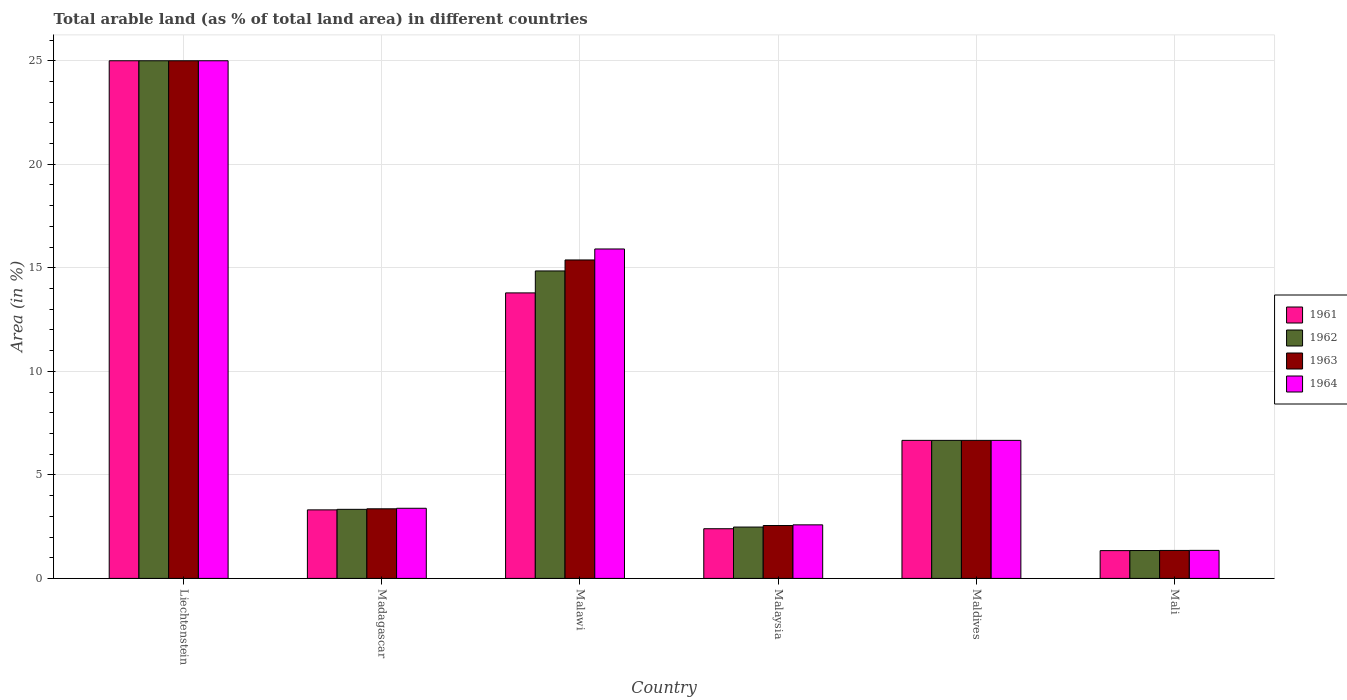How many groups of bars are there?
Offer a very short reply. 6. How many bars are there on the 4th tick from the left?
Your answer should be compact. 4. What is the label of the 1st group of bars from the left?
Provide a short and direct response. Liechtenstein. Across all countries, what is the maximum percentage of arable land in 1964?
Keep it short and to the point. 25. Across all countries, what is the minimum percentage of arable land in 1964?
Your response must be concise. 1.35. In which country was the percentage of arable land in 1962 maximum?
Your answer should be very brief. Liechtenstein. In which country was the percentage of arable land in 1964 minimum?
Offer a terse response. Mali. What is the total percentage of arable land in 1963 in the graph?
Your answer should be very brief. 54.31. What is the difference between the percentage of arable land in 1962 in Malawi and that in Mali?
Offer a very short reply. 13.5. What is the difference between the percentage of arable land in 1961 in Maldives and the percentage of arable land in 1962 in Malaysia?
Make the answer very short. 4.19. What is the average percentage of arable land in 1964 per country?
Offer a terse response. 9.15. In how many countries, is the percentage of arable land in 1964 greater than 13 %?
Give a very brief answer. 2. What is the ratio of the percentage of arable land in 1962 in Malawi to that in Mali?
Offer a terse response. 11.03. Is the percentage of arable land in 1962 in Madagascar less than that in Mali?
Give a very brief answer. No. Is the difference between the percentage of arable land in 1963 in Malawi and Malaysia greater than the difference between the percentage of arable land in 1961 in Malawi and Malaysia?
Make the answer very short. Yes. What is the difference between the highest and the second highest percentage of arable land in 1964?
Your response must be concise. 18.33. What is the difference between the highest and the lowest percentage of arable land in 1963?
Give a very brief answer. 23.65. Is the sum of the percentage of arable land in 1964 in Liechtenstein and Malaysia greater than the maximum percentage of arable land in 1961 across all countries?
Your answer should be very brief. Yes. Is it the case that in every country, the sum of the percentage of arable land in 1961 and percentage of arable land in 1962 is greater than the sum of percentage of arable land in 1964 and percentage of arable land in 1963?
Offer a terse response. No. What does the 1st bar from the right in Mali represents?
Your answer should be very brief. 1964. Does the graph contain any zero values?
Provide a succinct answer. No. Does the graph contain grids?
Offer a very short reply. Yes. What is the title of the graph?
Make the answer very short. Total arable land (as % of total land area) in different countries. What is the label or title of the Y-axis?
Your response must be concise. Area (in %). What is the Area (in %) of 1961 in Liechtenstein?
Your answer should be compact. 25. What is the Area (in %) in 1962 in Liechtenstein?
Keep it short and to the point. 25. What is the Area (in %) of 1963 in Liechtenstein?
Your response must be concise. 25. What is the Area (in %) in 1961 in Madagascar?
Provide a succinct answer. 3.31. What is the Area (in %) of 1962 in Madagascar?
Your answer should be compact. 3.34. What is the Area (in %) in 1963 in Madagascar?
Your response must be concise. 3.36. What is the Area (in %) of 1964 in Madagascar?
Your response must be concise. 3.39. What is the Area (in %) in 1961 in Malawi?
Make the answer very short. 13.79. What is the Area (in %) in 1962 in Malawi?
Keep it short and to the point. 14.85. What is the Area (in %) of 1963 in Malawi?
Ensure brevity in your answer.  15.38. What is the Area (in %) of 1964 in Malawi?
Ensure brevity in your answer.  15.91. What is the Area (in %) in 1961 in Malaysia?
Give a very brief answer. 2.4. What is the Area (in %) of 1962 in Malaysia?
Make the answer very short. 2.48. What is the Area (in %) of 1963 in Malaysia?
Offer a terse response. 2.55. What is the Area (in %) in 1964 in Malaysia?
Provide a succinct answer. 2.59. What is the Area (in %) of 1961 in Maldives?
Your answer should be compact. 6.67. What is the Area (in %) in 1962 in Maldives?
Provide a short and direct response. 6.67. What is the Area (in %) in 1963 in Maldives?
Offer a terse response. 6.67. What is the Area (in %) in 1964 in Maldives?
Offer a very short reply. 6.67. What is the Area (in %) of 1961 in Mali?
Keep it short and to the point. 1.34. What is the Area (in %) of 1962 in Mali?
Your answer should be compact. 1.35. What is the Area (in %) of 1963 in Mali?
Your answer should be very brief. 1.35. What is the Area (in %) of 1964 in Mali?
Provide a succinct answer. 1.35. Across all countries, what is the maximum Area (in %) of 1961?
Give a very brief answer. 25. Across all countries, what is the maximum Area (in %) of 1962?
Ensure brevity in your answer.  25. Across all countries, what is the minimum Area (in %) in 1961?
Offer a terse response. 1.34. Across all countries, what is the minimum Area (in %) in 1962?
Provide a succinct answer. 1.35. Across all countries, what is the minimum Area (in %) of 1963?
Offer a terse response. 1.35. Across all countries, what is the minimum Area (in %) in 1964?
Provide a succinct answer. 1.35. What is the total Area (in %) of 1961 in the graph?
Make the answer very short. 52.51. What is the total Area (in %) in 1962 in the graph?
Ensure brevity in your answer.  53.68. What is the total Area (in %) in 1963 in the graph?
Keep it short and to the point. 54.31. What is the total Area (in %) of 1964 in the graph?
Provide a short and direct response. 54.91. What is the difference between the Area (in %) of 1961 in Liechtenstein and that in Madagascar?
Offer a terse response. 21.69. What is the difference between the Area (in %) in 1962 in Liechtenstein and that in Madagascar?
Give a very brief answer. 21.66. What is the difference between the Area (in %) in 1963 in Liechtenstein and that in Madagascar?
Ensure brevity in your answer.  21.64. What is the difference between the Area (in %) in 1964 in Liechtenstein and that in Madagascar?
Your answer should be very brief. 21.61. What is the difference between the Area (in %) in 1961 in Liechtenstein and that in Malawi?
Your answer should be compact. 11.21. What is the difference between the Area (in %) of 1962 in Liechtenstein and that in Malawi?
Ensure brevity in your answer.  10.15. What is the difference between the Area (in %) in 1963 in Liechtenstein and that in Malawi?
Your answer should be very brief. 9.62. What is the difference between the Area (in %) in 1964 in Liechtenstein and that in Malawi?
Offer a very short reply. 9.09. What is the difference between the Area (in %) in 1961 in Liechtenstein and that in Malaysia?
Make the answer very short. 22.6. What is the difference between the Area (in %) of 1962 in Liechtenstein and that in Malaysia?
Your response must be concise. 22.52. What is the difference between the Area (in %) of 1963 in Liechtenstein and that in Malaysia?
Your answer should be very brief. 22.45. What is the difference between the Area (in %) in 1964 in Liechtenstein and that in Malaysia?
Make the answer very short. 22.41. What is the difference between the Area (in %) in 1961 in Liechtenstein and that in Maldives?
Provide a succinct answer. 18.33. What is the difference between the Area (in %) in 1962 in Liechtenstein and that in Maldives?
Offer a very short reply. 18.33. What is the difference between the Area (in %) of 1963 in Liechtenstein and that in Maldives?
Give a very brief answer. 18.33. What is the difference between the Area (in %) in 1964 in Liechtenstein and that in Maldives?
Provide a succinct answer. 18.33. What is the difference between the Area (in %) of 1961 in Liechtenstein and that in Mali?
Provide a succinct answer. 23.66. What is the difference between the Area (in %) of 1962 in Liechtenstein and that in Mali?
Your answer should be compact. 23.65. What is the difference between the Area (in %) of 1963 in Liechtenstein and that in Mali?
Offer a very short reply. 23.65. What is the difference between the Area (in %) in 1964 in Liechtenstein and that in Mali?
Provide a succinct answer. 23.65. What is the difference between the Area (in %) of 1961 in Madagascar and that in Malawi?
Your answer should be compact. -10.48. What is the difference between the Area (in %) of 1962 in Madagascar and that in Malawi?
Your answer should be very brief. -11.51. What is the difference between the Area (in %) of 1963 in Madagascar and that in Malawi?
Offer a terse response. -12.02. What is the difference between the Area (in %) of 1964 in Madagascar and that in Malawi?
Your response must be concise. -12.52. What is the difference between the Area (in %) in 1961 in Madagascar and that in Malaysia?
Offer a terse response. 0.91. What is the difference between the Area (in %) in 1962 in Madagascar and that in Malaysia?
Make the answer very short. 0.86. What is the difference between the Area (in %) of 1963 in Madagascar and that in Malaysia?
Ensure brevity in your answer.  0.81. What is the difference between the Area (in %) in 1964 in Madagascar and that in Malaysia?
Offer a very short reply. 0.8. What is the difference between the Area (in %) in 1961 in Madagascar and that in Maldives?
Keep it short and to the point. -3.36. What is the difference between the Area (in %) in 1962 in Madagascar and that in Maldives?
Keep it short and to the point. -3.33. What is the difference between the Area (in %) of 1963 in Madagascar and that in Maldives?
Give a very brief answer. -3.3. What is the difference between the Area (in %) of 1964 in Madagascar and that in Maldives?
Give a very brief answer. -3.28. What is the difference between the Area (in %) of 1961 in Madagascar and that in Mali?
Provide a succinct answer. 1.97. What is the difference between the Area (in %) of 1962 in Madagascar and that in Mali?
Offer a very short reply. 1.99. What is the difference between the Area (in %) in 1963 in Madagascar and that in Mali?
Provide a short and direct response. 2.01. What is the difference between the Area (in %) of 1964 in Madagascar and that in Mali?
Offer a terse response. 2.03. What is the difference between the Area (in %) in 1961 in Malawi and that in Malaysia?
Offer a very short reply. 11.39. What is the difference between the Area (in %) in 1962 in Malawi and that in Malaysia?
Offer a terse response. 12.37. What is the difference between the Area (in %) of 1963 in Malawi and that in Malaysia?
Your answer should be compact. 12.83. What is the difference between the Area (in %) of 1964 in Malawi and that in Malaysia?
Your response must be concise. 13.32. What is the difference between the Area (in %) in 1961 in Malawi and that in Maldives?
Your answer should be compact. 7.12. What is the difference between the Area (in %) in 1962 in Malawi and that in Maldives?
Offer a very short reply. 8.18. What is the difference between the Area (in %) of 1963 in Malawi and that in Maldives?
Ensure brevity in your answer.  8.71. What is the difference between the Area (in %) of 1964 in Malawi and that in Maldives?
Keep it short and to the point. 9.24. What is the difference between the Area (in %) of 1961 in Malawi and that in Mali?
Make the answer very short. 12.45. What is the difference between the Area (in %) in 1962 in Malawi and that in Mali?
Ensure brevity in your answer.  13.5. What is the difference between the Area (in %) in 1963 in Malawi and that in Mali?
Make the answer very short. 14.03. What is the difference between the Area (in %) in 1964 in Malawi and that in Mali?
Provide a short and direct response. 14.56. What is the difference between the Area (in %) of 1961 in Malaysia and that in Maldives?
Ensure brevity in your answer.  -4.27. What is the difference between the Area (in %) in 1962 in Malaysia and that in Maldives?
Ensure brevity in your answer.  -4.19. What is the difference between the Area (in %) of 1963 in Malaysia and that in Maldives?
Keep it short and to the point. -4.11. What is the difference between the Area (in %) in 1964 in Malaysia and that in Maldives?
Offer a very short reply. -4.08. What is the difference between the Area (in %) in 1961 in Malaysia and that in Mali?
Give a very brief answer. 1.06. What is the difference between the Area (in %) in 1962 in Malaysia and that in Mali?
Ensure brevity in your answer.  1.13. What is the difference between the Area (in %) of 1963 in Malaysia and that in Mali?
Offer a very short reply. 1.2. What is the difference between the Area (in %) in 1964 in Malaysia and that in Mali?
Keep it short and to the point. 1.23. What is the difference between the Area (in %) of 1961 in Maldives and that in Mali?
Provide a short and direct response. 5.32. What is the difference between the Area (in %) in 1962 in Maldives and that in Mali?
Provide a short and direct response. 5.32. What is the difference between the Area (in %) of 1963 in Maldives and that in Mali?
Ensure brevity in your answer.  5.32. What is the difference between the Area (in %) of 1964 in Maldives and that in Mali?
Offer a very short reply. 5.31. What is the difference between the Area (in %) in 1961 in Liechtenstein and the Area (in %) in 1962 in Madagascar?
Provide a succinct answer. 21.66. What is the difference between the Area (in %) of 1961 in Liechtenstein and the Area (in %) of 1963 in Madagascar?
Keep it short and to the point. 21.64. What is the difference between the Area (in %) in 1961 in Liechtenstein and the Area (in %) in 1964 in Madagascar?
Your answer should be very brief. 21.61. What is the difference between the Area (in %) of 1962 in Liechtenstein and the Area (in %) of 1963 in Madagascar?
Provide a short and direct response. 21.64. What is the difference between the Area (in %) in 1962 in Liechtenstein and the Area (in %) in 1964 in Madagascar?
Make the answer very short. 21.61. What is the difference between the Area (in %) of 1963 in Liechtenstein and the Area (in %) of 1964 in Madagascar?
Give a very brief answer. 21.61. What is the difference between the Area (in %) in 1961 in Liechtenstein and the Area (in %) in 1962 in Malawi?
Provide a short and direct response. 10.15. What is the difference between the Area (in %) in 1961 in Liechtenstein and the Area (in %) in 1963 in Malawi?
Provide a succinct answer. 9.62. What is the difference between the Area (in %) of 1961 in Liechtenstein and the Area (in %) of 1964 in Malawi?
Ensure brevity in your answer.  9.09. What is the difference between the Area (in %) of 1962 in Liechtenstein and the Area (in %) of 1963 in Malawi?
Ensure brevity in your answer.  9.62. What is the difference between the Area (in %) in 1962 in Liechtenstein and the Area (in %) in 1964 in Malawi?
Provide a succinct answer. 9.09. What is the difference between the Area (in %) of 1963 in Liechtenstein and the Area (in %) of 1964 in Malawi?
Offer a very short reply. 9.09. What is the difference between the Area (in %) in 1961 in Liechtenstein and the Area (in %) in 1962 in Malaysia?
Your answer should be compact. 22.52. What is the difference between the Area (in %) of 1961 in Liechtenstein and the Area (in %) of 1963 in Malaysia?
Offer a terse response. 22.45. What is the difference between the Area (in %) in 1961 in Liechtenstein and the Area (in %) in 1964 in Malaysia?
Make the answer very short. 22.41. What is the difference between the Area (in %) in 1962 in Liechtenstein and the Area (in %) in 1963 in Malaysia?
Your answer should be compact. 22.45. What is the difference between the Area (in %) in 1962 in Liechtenstein and the Area (in %) in 1964 in Malaysia?
Your answer should be compact. 22.41. What is the difference between the Area (in %) of 1963 in Liechtenstein and the Area (in %) of 1964 in Malaysia?
Ensure brevity in your answer.  22.41. What is the difference between the Area (in %) of 1961 in Liechtenstein and the Area (in %) of 1962 in Maldives?
Your response must be concise. 18.33. What is the difference between the Area (in %) in 1961 in Liechtenstein and the Area (in %) in 1963 in Maldives?
Ensure brevity in your answer.  18.33. What is the difference between the Area (in %) of 1961 in Liechtenstein and the Area (in %) of 1964 in Maldives?
Give a very brief answer. 18.33. What is the difference between the Area (in %) of 1962 in Liechtenstein and the Area (in %) of 1963 in Maldives?
Make the answer very short. 18.33. What is the difference between the Area (in %) of 1962 in Liechtenstein and the Area (in %) of 1964 in Maldives?
Keep it short and to the point. 18.33. What is the difference between the Area (in %) in 1963 in Liechtenstein and the Area (in %) in 1964 in Maldives?
Your response must be concise. 18.33. What is the difference between the Area (in %) in 1961 in Liechtenstein and the Area (in %) in 1962 in Mali?
Ensure brevity in your answer.  23.65. What is the difference between the Area (in %) of 1961 in Liechtenstein and the Area (in %) of 1963 in Mali?
Provide a short and direct response. 23.65. What is the difference between the Area (in %) in 1961 in Liechtenstein and the Area (in %) in 1964 in Mali?
Provide a succinct answer. 23.65. What is the difference between the Area (in %) in 1962 in Liechtenstein and the Area (in %) in 1963 in Mali?
Your answer should be compact. 23.65. What is the difference between the Area (in %) in 1962 in Liechtenstein and the Area (in %) in 1964 in Mali?
Make the answer very short. 23.65. What is the difference between the Area (in %) in 1963 in Liechtenstein and the Area (in %) in 1964 in Mali?
Make the answer very short. 23.65. What is the difference between the Area (in %) of 1961 in Madagascar and the Area (in %) of 1962 in Malawi?
Your answer should be very brief. -11.54. What is the difference between the Area (in %) of 1961 in Madagascar and the Area (in %) of 1963 in Malawi?
Make the answer very short. -12.07. What is the difference between the Area (in %) of 1961 in Madagascar and the Area (in %) of 1964 in Malawi?
Your answer should be very brief. -12.6. What is the difference between the Area (in %) of 1962 in Madagascar and the Area (in %) of 1963 in Malawi?
Give a very brief answer. -12.04. What is the difference between the Area (in %) in 1962 in Madagascar and the Area (in %) in 1964 in Malawi?
Provide a succinct answer. -12.57. What is the difference between the Area (in %) of 1963 in Madagascar and the Area (in %) of 1964 in Malawi?
Offer a very short reply. -12.55. What is the difference between the Area (in %) of 1961 in Madagascar and the Area (in %) of 1962 in Malaysia?
Offer a very short reply. 0.83. What is the difference between the Area (in %) of 1961 in Madagascar and the Area (in %) of 1963 in Malaysia?
Offer a very short reply. 0.76. What is the difference between the Area (in %) of 1961 in Madagascar and the Area (in %) of 1964 in Malaysia?
Make the answer very short. 0.72. What is the difference between the Area (in %) in 1962 in Madagascar and the Area (in %) in 1963 in Malaysia?
Keep it short and to the point. 0.78. What is the difference between the Area (in %) in 1962 in Madagascar and the Area (in %) in 1964 in Malaysia?
Offer a very short reply. 0.75. What is the difference between the Area (in %) in 1963 in Madagascar and the Area (in %) in 1964 in Malaysia?
Provide a succinct answer. 0.77. What is the difference between the Area (in %) of 1961 in Madagascar and the Area (in %) of 1962 in Maldives?
Keep it short and to the point. -3.36. What is the difference between the Area (in %) of 1961 in Madagascar and the Area (in %) of 1963 in Maldives?
Your response must be concise. -3.36. What is the difference between the Area (in %) in 1961 in Madagascar and the Area (in %) in 1964 in Maldives?
Ensure brevity in your answer.  -3.36. What is the difference between the Area (in %) of 1962 in Madagascar and the Area (in %) of 1963 in Maldives?
Your answer should be compact. -3.33. What is the difference between the Area (in %) of 1962 in Madagascar and the Area (in %) of 1964 in Maldives?
Your answer should be very brief. -3.33. What is the difference between the Area (in %) of 1963 in Madagascar and the Area (in %) of 1964 in Maldives?
Provide a short and direct response. -3.3. What is the difference between the Area (in %) of 1961 in Madagascar and the Area (in %) of 1962 in Mali?
Offer a terse response. 1.96. What is the difference between the Area (in %) of 1961 in Madagascar and the Area (in %) of 1963 in Mali?
Your answer should be very brief. 1.96. What is the difference between the Area (in %) in 1961 in Madagascar and the Area (in %) in 1964 in Mali?
Provide a succinct answer. 1.96. What is the difference between the Area (in %) of 1962 in Madagascar and the Area (in %) of 1963 in Mali?
Give a very brief answer. 1.99. What is the difference between the Area (in %) in 1962 in Madagascar and the Area (in %) in 1964 in Mali?
Ensure brevity in your answer.  1.98. What is the difference between the Area (in %) in 1963 in Madagascar and the Area (in %) in 1964 in Mali?
Your answer should be compact. 2.01. What is the difference between the Area (in %) in 1961 in Malawi and the Area (in %) in 1962 in Malaysia?
Ensure brevity in your answer.  11.31. What is the difference between the Area (in %) in 1961 in Malawi and the Area (in %) in 1963 in Malaysia?
Make the answer very short. 11.23. What is the difference between the Area (in %) in 1961 in Malawi and the Area (in %) in 1964 in Malaysia?
Offer a terse response. 11.2. What is the difference between the Area (in %) in 1962 in Malawi and the Area (in %) in 1963 in Malaysia?
Keep it short and to the point. 12.3. What is the difference between the Area (in %) in 1962 in Malawi and the Area (in %) in 1964 in Malaysia?
Give a very brief answer. 12.26. What is the difference between the Area (in %) of 1963 in Malawi and the Area (in %) of 1964 in Malaysia?
Offer a terse response. 12.79. What is the difference between the Area (in %) in 1961 in Malawi and the Area (in %) in 1962 in Maldives?
Your answer should be compact. 7.12. What is the difference between the Area (in %) in 1961 in Malawi and the Area (in %) in 1963 in Maldives?
Your response must be concise. 7.12. What is the difference between the Area (in %) of 1961 in Malawi and the Area (in %) of 1964 in Maldives?
Your response must be concise. 7.12. What is the difference between the Area (in %) of 1962 in Malawi and the Area (in %) of 1963 in Maldives?
Your response must be concise. 8.18. What is the difference between the Area (in %) in 1962 in Malawi and the Area (in %) in 1964 in Maldives?
Your response must be concise. 8.18. What is the difference between the Area (in %) of 1963 in Malawi and the Area (in %) of 1964 in Maldives?
Ensure brevity in your answer.  8.71. What is the difference between the Area (in %) of 1961 in Malawi and the Area (in %) of 1962 in Mali?
Give a very brief answer. 12.44. What is the difference between the Area (in %) of 1961 in Malawi and the Area (in %) of 1963 in Mali?
Provide a short and direct response. 12.44. What is the difference between the Area (in %) of 1961 in Malawi and the Area (in %) of 1964 in Mali?
Provide a short and direct response. 12.43. What is the difference between the Area (in %) of 1962 in Malawi and the Area (in %) of 1963 in Mali?
Provide a short and direct response. 13.5. What is the difference between the Area (in %) in 1962 in Malawi and the Area (in %) in 1964 in Mali?
Your answer should be compact. 13.49. What is the difference between the Area (in %) in 1963 in Malawi and the Area (in %) in 1964 in Mali?
Offer a terse response. 14.03. What is the difference between the Area (in %) in 1961 in Malaysia and the Area (in %) in 1962 in Maldives?
Keep it short and to the point. -4.27. What is the difference between the Area (in %) of 1961 in Malaysia and the Area (in %) of 1963 in Maldives?
Keep it short and to the point. -4.27. What is the difference between the Area (in %) of 1961 in Malaysia and the Area (in %) of 1964 in Maldives?
Your response must be concise. -4.27. What is the difference between the Area (in %) in 1962 in Malaysia and the Area (in %) in 1963 in Maldives?
Give a very brief answer. -4.19. What is the difference between the Area (in %) in 1962 in Malaysia and the Area (in %) in 1964 in Maldives?
Your answer should be very brief. -4.19. What is the difference between the Area (in %) in 1963 in Malaysia and the Area (in %) in 1964 in Maldives?
Offer a terse response. -4.11. What is the difference between the Area (in %) of 1961 in Malaysia and the Area (in %) of 1962 in Mali?
Your answer should be very brief. 1.05. What is the difference between the Area (in %) in 1961 in Malaysia and the Area (in %) in 1963 in Mali?
Offer a very short reply. 1.05. What is the difference between the Area (in %) in 1961 in Malaysia and the Area (in %) in 1964 in Mali?
Ensure brevity in your answer.  1.05. What is the difference between the Area (in %) in 1962 in Malaysia and the Area (in %) in 1963 in Mali?
Make the answer very short. 1.13. What is the difference between the Area (in %) in 1962 in Malaysia and the Area (in %) in 1964 in Mali?
Provide a succinct answer. 1.13. What is the difference between the Area (in %) of 1963 in Malaysia and the Area (in %) of 1964 in Mali?
Your answer should be very brief. 1.2. What is the difference between the Area (in %) in 1961 in Maldives and the Area (in %) in 1962 in Mali?
Make the answer very short. 5.32. What is the difference between the Area (in %) in 1961 in Maldives and the Area (in %) in 1963 in Mali?
Your answer should be very brief. 5.32. What is the difference between the Area (in %) in 1961 in Maldives and the Area (in %) in 1964 in Mali?
Make the answer very short. 5.31. What is the difference between the Area (in %) in 1962 in Maldives and the Area (in %) in 1963 in Mali?
Ensure brevity in your answer.  5.32. What is the difference between the Area (in %) in 1962 in Maldives and the Area (in %) in 1964 in Mali?
Your response must be concise. 5.31. What is the difference between the Area (in %) in 1963 in Maldives and the Area (in %) in 1964 in Mali?
Give a very brief answer. 5.31. What is the average Area (in %) of 1961 per country?
Your answer should be very brief. 8.75. What is the average Area (in %) of 1962 per country?
Your answer should be very brief. 8.95. What is the average Area (in %) in 1963 per country?
Your answer should be very brief. 9.05. What is the average Area (in %) of 1964 per country?
Offer a very short reply. 9.15. What is the difference between the Area (in %) in 1961 and Area (in %) in 1962 in Liechtenstein?
Provide a short and direct response. 0. What is the difference between the Area (in %) in 1961 and Area (in %) in 1963 in Liechtenstein?
Provide a succinct answer. 0. What is the difference between the Area (in %) in 1962 and Area (in %) in 1963 in Liechtenstein?
Your response must be concise. 0. What is the difference between the Area (in %) in 1962 and Area (in %) in 1964 in Liechtenstein?
Offer a terse response. 0. What is the difference between the Area (in %) of 1961 and Area (in %) of 1962 in Madagascar?
Offer a terse response. -0.03. What is the difference between the Area (in %) in 1961 and Area (in %) in 1963 in Madagascar?
Provide a short and direct response. -0.05. What is the difference between the Area (in %) in 1961 and Area (in %) in 1964 in Madagascar?
Ensure brevity in your answer.  -0.08. What is the difference between the Area (in %) of 1962 and Area (in %) of 1963 in Madagascar?
Offer a very short reply. -0.03. What is the difference between the Area (in %) of 1962 and Area (in %) of 1964 in Madagascar?
Offer a very short reply. -0.05. What is the difference between the Area (in %) of 1963 and Area (in %) of 1964 in Madagascar?
Give a very brief answer. -0.03. What is the difference between the Area (in %) of 1961 and Area (in %) of 1962 in Malawi?
Provide a succinct answer. -1.06. What is the difference between the Area (in %) of 1961 and Area (in %) of 1963 in Malawi?
Provide a succinct answer. -1.59. What is the difference between the Area (in %) of 1961 and Area (in %) of 1964 in Malawi?
Offer a very short reply. -2.12. What is the difference between the Area (in %) of 1962 and Area (in %) of 1963 in Malawi?
Make the answer very short. -0.53. What is the difference between the Area (in %) in 1962 and Area (in %) in 1964 in Malawi?
Your answer should be very brief. -1.06. What is the difference between the Area (in %) of 1963 and Area (in %) of 1964 in Malawi?
Ensure brevity in your answer.  -0.53. What is the difference between the Area (in %) in 1961 and Area (in %) in 1962 in Malaysia?
Your answer should be very brief. -0.08. What is the difference between the Area (in %) of 1961 and Area (in %) of 1963 in Malaysia?
Give a very brief answer. -0.15. What is the difference between the Area (in %) of 1961 and Area (in %) of 1964 in Malaysia?
Provide a short and direct response. -0.19. What is the difference between the Area (in %) of 1962 and Area (in %) of 1963 in Malaysia?
Your answer should be compact. -0.07. What is the difference between the Area (in %) of 1962 and Area (in %) of 1964 in Malaysia?
Ensure brevity in your answer.  -0.11. What is the difference between the Area (in %) in 1963 and Area (in %) in 1964 in Malaysia?
Provide a short and direct response. -0.03. What is the difference between the Area (in %) of 1961 and Area (in %) of 1964 in Maldives?
Provide a short and direct response. 0. What is the difference between the Area (in %) in 1962 and Area (in %) in 1963 in Maldives?
Provide a short and direct response. 0. What is the difference between the Area (in %) of 1962 and Area (in %) of 1964 in Maldives?
Your answer should be compact. 0. What is the difference between the Area (in %) of 1963 and Area (in %) of 1964 in Maldives?
Your response must be concise. 0. What is the difference between the Area (in %) in 1961 and Area (in %) in 1962 in Mali?
Give a very brief answer. -0. What is the difference between the Area (in %) of 1961 and Area (in %) of 1963 in Mali?
Offer a terse response. -0.01. What is the difference between the Area (in %) in 1961 and Area (in %) in 1964 in Mali?
Provide a short and direct response. -0.01. What is the difference between the Area (in %) of 1962 and Area (in %) of 1963 in Mali?
Offer a terse response. -0. What is the difference between the Area (in %) in 1962 and Area (in %) in 1964 in Mali?
Provide a succinct answer. -0.01. What is the difference between the Area (in %) in 1963 and Area (in %) in 1964 in Mali?
Your answer should be compact. -0. What is the ratio of the Area (in %) in 1961 in Liechtenstein to that in Madagascar?
Ensure brevity in your answer.  7.55. What is the ratio of the Area (in %) in 1962 in Liechtenstein to that in Madagascar?
Your answer should be very brief. 7.49. What is the ratio of the Area (in %) in 1963 in Liechtenstein to that in Madagascar?
Ensure brevity in your answer.  7.44. What is the ratio of the Area (in %) in 1964 in Liechtenstein to that in Madagascar?
Provide a succinct answer. 7.38. What is the ratio of the Area (in %) of 1961 in Liechtenstein to that in Malawi?
Offer a terse response. 1.81. What is the ratio of the Area (in %) in 1962 in Liechtenstein to that in Malawi?
Make the answer very short. 1.68. What is the ratio of the Area (in %) of 1963 in Liechtenstein to that in Malawi?
Provide a short and direct response. 1.63. What is the ratio of the Area (in %) of 1964 in Liechtenstein to that in Malawi?
Your answer should be very brief. 1.57. What is the ratio of the Area (in %) of 1961 in Liechtenstein to that in Malaysia?
Keep it short and to the point. 10.42. What is the ratio of the Area (in %) in 1962 in Liechtenstein to that in Malaysia?
Make the answer very short. 10.08. What is the ratio of the Area (in %) in 1963 in Liechtenstein to that in Malaysia?
Offer a terse response. 9.79. What is the ratio of the Area (in %) in 1964 in Liechtenstein to that in Malaysia?
Offer a terse response. 9.66. What is the ratio of the Area (in %) in 1961 in Liechtenstein to that in Maldives?
Your response must be concise. 3.75. What is the ratio of the Area (in %) in 1962 in Liechtenstein to that in Maldives?
Provide a short and direct response. 3.75. What is the ratio of the Area (in %) of 1963 in Liechtenstein to that in Maldives?
Offer a very short reply. 3.75. What is the ratio of the Area (in %) in 1964 in Liechtenstein to that in Maldives?
Provide a succinct answer. 3.75. What is the ratio of the Area (in %) in 1961 in Liechtenstein to that in Mali?
Offer a terse response. 18.62. What is the ratio of the Area (in %) in 1962 in Liechtenstein to that in Mali?
Provide a short and direct response. 18.57. What is the ratio of the Area (in %) in 1963 in Liechtenstein to that in Mali?
Offer a terse response. 18.51. What is the ratio of the Area (in %) of 1964 in Liechtenstein to that in Mali?
Ensure brevity in your answer.  18.45. What is the ratio of the Area (in %) of 1961 in Madagascar to that in Malawi?
Offer a terse response. 0.24. What is the ratio of the Area (in %) in 1962 in Madagascar to that in Malawi?
Make the answer very short. 0.22. What is the ratio of the Area (in %) in 1963 in Madagascar to that in Malawi?
Your response must be concise. 0.22. What is the ratio of the Area (in %) of 1964 in Madagascar to that in Malawi?
Offer a terse response. 0.21. What is the ratio of the Area (in %) of 1961 in Madagascar to that in Malaysia?
Make the answer very short. 1.38. What is the ratio of the Area (in %) in 1962 in Madagascar to that in Malaysia?
Provide a short and direct response. 1.35. What is the ratio of the Area (in %) in 1963 in Madagascar to that in Malaysia?
Provide a short and direct response. 1.32. What is the ratio of the Area (in %) in 1964 in Madagascar to that in Malaysia?
Offer a terse response. 1.31. What is the ratio of the Area (in %) in 1961 in Madagascar to that in Maldives?
Offer a very short reply. 0.5. What is the ratio of the Area (in %) of 1962 in Madagascar to that in Maldives?
Make the answer very short. 0.5. What is the ratio of the Area (in %) of 1963 in Madagascar to that in Maldives?
Make the answer very short. 0.5. What is the ratio of the Area (in %) in 1964 in Madagascar to that in Maldives?
Ensure brevity in your answer.  0.51. What is the ratio of the Area (in %) in 1961 in Madagascar to that in Mali?
Offer a very short reply. 2.47. What is the ratio of the Area (in %) in 1962 in Madagascar to that in Mali?
Provide a short and direct response. 2.48. What is the ratio of the Area (in %) in 1963 in Madagascar to that in Mali?
Offer a terse response. 2.49. What is the ratio of the Area (in %) of 1964 in Madagascar to that in Mali?
Keep it short and to the point. 2.5. What is the ratio of the Area (in %) of 1961 in Malawi to that in Malaysia?
Make the answer very short. 5.75. What is the ratio of the Area (in %) of 1962 in Malawi to that in Malaysia?
Offer a terse response. 5.99. What is the ratio of the Area (in %) in 1963 in Malawi to that in Malaysia?
Ensure brevity in your answer.  6.02. What is the ratio of the Area (in %) of 1964 in Malawi to that in Malaysia?
Give a very brief answer. 6.15. What is the ratio of the Area (in %) in 1961 in Malawi to that in Maldives?
Your answer should be very brief. 2.07. What is the ratio of the Area (in %) of 1962 in Malawi to that in Maldives?
Give a very brief answer. 2.23. What is the ratio of the Area (in %) of 1963 in Malawi to that in Maldives?
Provide a succinct answer. 2.31. What is the ratio of the Area (in %) of 1964 in Malawi to that in Maldives?
Your response must be concise. 2.39. What is the ratio of the Area (in %) in 1961 in Malawi to that in Mali?
Your answer should be very brief. 10.27. What is the ratio of the Area (in %) of 1962 in Malawi to that in Mali?
Provide a short and direct response. 11.03. What is the ratio of the Area (in %) in 1963 in Malawi to that in Mali?
Your answer should be compact. 11.39. What is the ratio of the Area (in %) of 1964 in Malawi to that in Mali?
Make the answer very short. 11.74. What is the ratio of the Area (in %) in 1961 in Malaysia to that in Maldives?
Offer a very short reply. 0.36. What is the ratio of the Area (in %) in 1962 in Malaysia to that in Maldives?
Provide a short and direct response. 0.37. What is the ratio of the Area (in %) of 1963 in Malaysia to that in Maldives?
Provide a short and direct response. 0.38. What is the ratio of the Area (in %) in 1964 in Malaysia to that in Maldives?
Provide a short and direct response. 0.39. What is the ratio of the Area (in %) of 1961 in Malaysia to that in Mali?
Your response must be concise. 1.79. What is the ratio of the Area (in %) of 1962 in Malaysia to that in Mali?
Your response must be concise. 1.84. What is the ratio of the Area (in %) of 1963 in Malaysia to that in Mali?
Your answer should be very brief. 1.89. What is the ratio of the Area (in %) of 1964 in Malaysia to that in Mali?
Provide a short and direct response. 1.91. What is the ratio of the Area (in %) in 1961 in Maldives to that in Mali?
Keep it short and to the point. 4.97. What is the ratio of the Area (in %) in 1962 in Maldives to that in Mali?
Keep it short and to the point. 4.95. What is the ratio of the Area (in %) of 1963 in Maldives to that in Mali?
Make the answer very short. 4.94. What is the ratio of the Area (in %) of 1964 in Maldives to that in Mali?
Your answer should be very brief. 4.92. What is the difference between the highest and the second highest Area (in %) in 1961?
Offer a terse response. 11.21. What is the difference between the highest and the second highest Area (in %) of 1962?
Give a very brief answer. 10.15. What is the difference between the highest and the second highest Area (in %) of 1963?
Make the answer very short. 9.62. What is the difference between the highest and the second highest Area (in %) in 1964?
Provide a succinct answer. 9.09. What is the difference between the highest and the lowest Area (in %) in 1961?
Keep it short and to the point. 23.66. What is the difference between the highest and the lowest Area (in %) in 1962?
Your response must be concise. 23.65. What is the difference between the highest and the lowest Area (in %) in 1963?
Your answer should be very brief. 23.65. What is the difference between the highest and the lowest Area (in %) of 1964?
Provide a succinct answer. 23.65. 